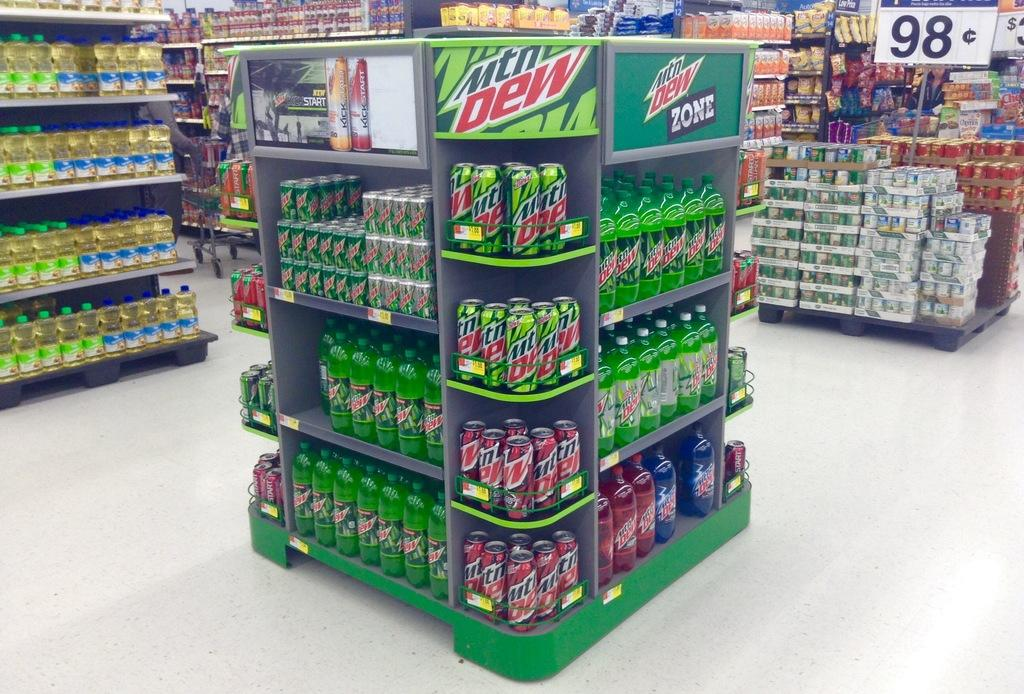Provide a one-sentence caption for the provided image. In a grocery store there is a display for mountain dew. 